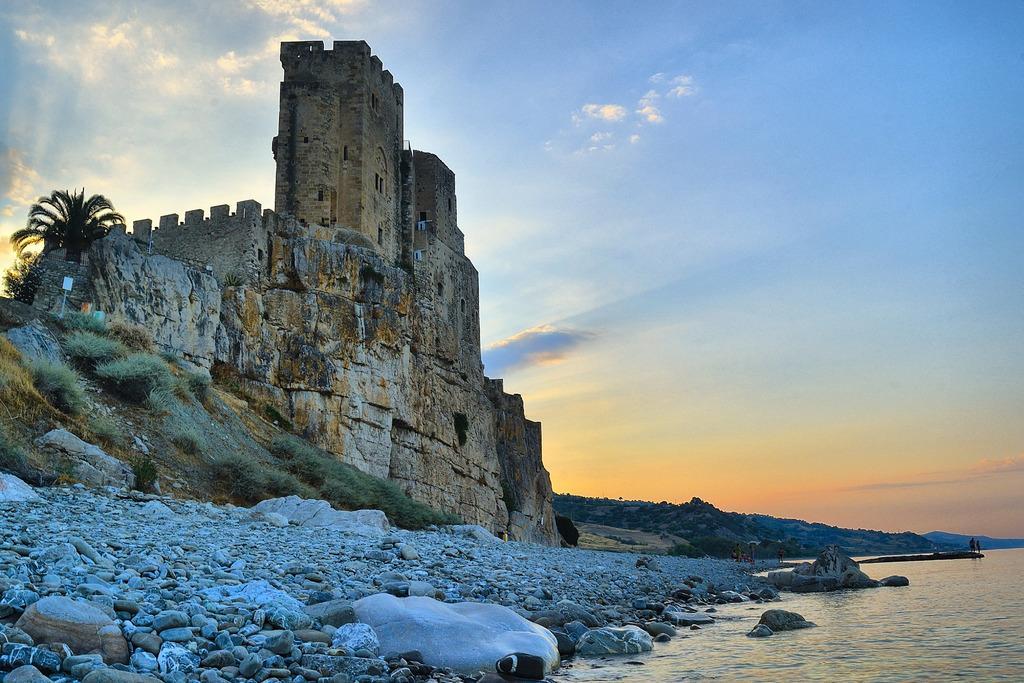How would you summarize this image in a sentence or two? We can see water, rocks, stones, grass, board on pole, tree and fort. In the background we can see hills, people and sky with clouds. 